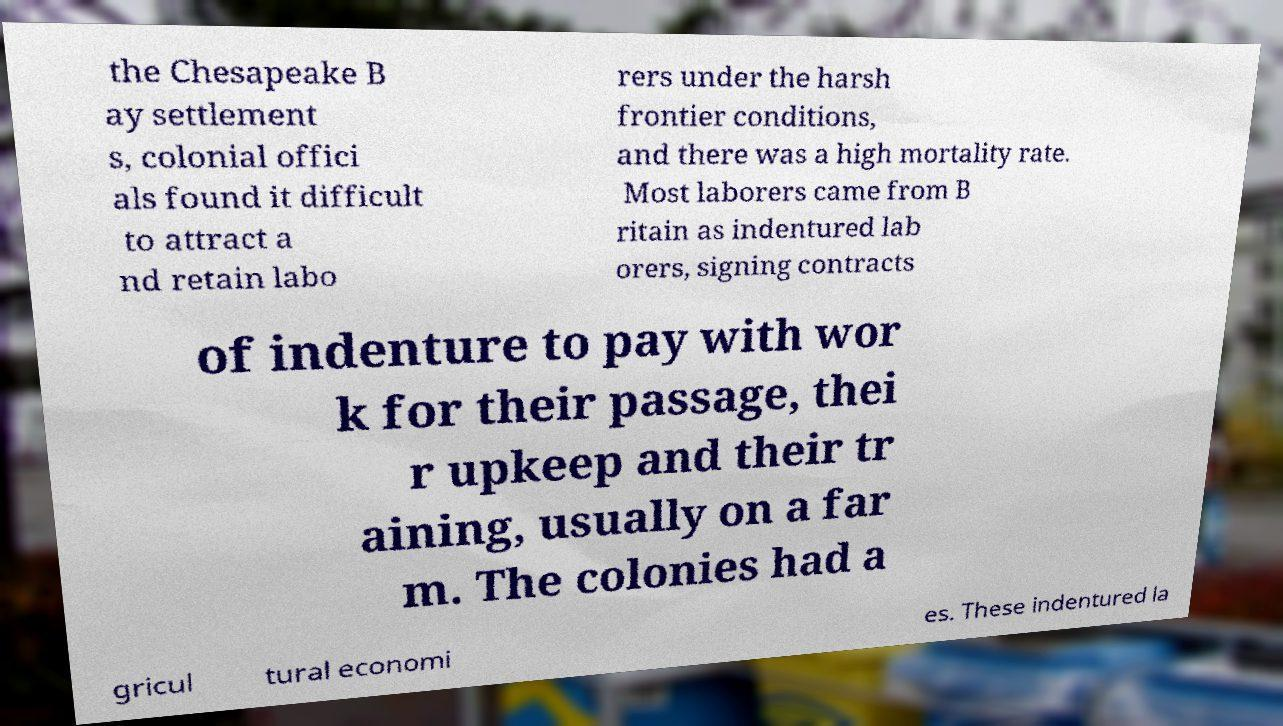Could you assist in decoding the text presented in this image and type it out clearly? the Chesapeake B ay settlement s, colonial offici als found it difficult to attract a nd retain labo rers under the harsh frontier conditions, and there was a high mortality rate. Most laborers came from B ritain as indentured lab orers, signing contracts of indenture to pay with wor k for their passage, thei r upkeep and their tr aining, usually on a far m. The colonies had a gricul tural economi es. These indentured la 